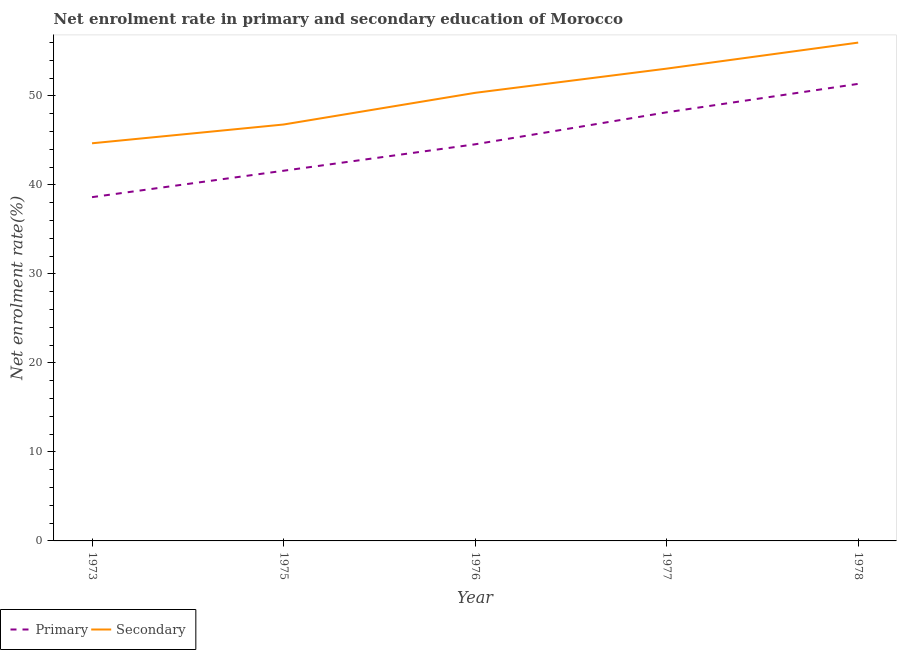How many different coloured lines are there?
Provide a succinct answer. 2. What is the enrollment rate in secondary education in 1977?
Offer a terse response. 53.07. Across all years, what is the maximum enrollment rate in secondary education?
Offer a very short reply. 55.99. Across all years, what is the minimum enrollment rate in primary education?
Offer a very short reply. 38.63. In which year was the enrollment rate in primary education maximum?
Offer a very short reply. 1978. In which year was the enrollment rate in secondary education minimum?
Give a very brief answer. 1973. What is the total enrollment rate in primary education in the graph?
Provide a succinct answer. 224.3. What is the difference between the enrollment rate in secondary education in 1973 and that in 1978?
Offer a terse response. -11.31. What is the difference between the enrollment rate in primary education in 1977 and the enrollment rate in secondary education in 1975?
Offer a terse response. 1.37. What is the average enrollment rate in secondary education per year?
Your answer should be very brief. 50.17. In the year 1976, what is the difference between the enrollment rate in secondary education and enrollment rate in primary education?
Your response must be concise. 5.78. What is the ratio of the enrollment rate in secondary education in 1975 to that in 1978?
Ensure brevity in your answer.  0.84. Is the difference between the enrollment rate in secondary education in 1973 and 1976 greater than the difference between the enrollment rate in primary education in 1973 and 1976?
Give a very brief answer. Yes. What is the difference between the highest and the second highest enrollment rate in secondary education?
Make the answer very short. 2.92. What is the difference between the highest and the lowest enrollment rate in secondary education?
Offer a terse response. 11.31. In how many years, is the enrollment rate in secondary education greater than the average enrollment rate in secondary education taken over all years?
Offer a terse response. 3. Does the enrollment rate in primary education monotonically increase over the years?
Offer a very short reply. Yes. Is the enrollment rate in secondary education strictly greater than the enrollment rate in primary education over the years?
Ensure brevity in your answer.  Yes. Is the enrollment rate in primary education strictly less than the enrollment rate in secondary education over the years?
Make the answer very short. Yes. How many lines are there?
Provide a succinct answer. 2. How many years are there in the graph?
Ensure brevity in your answer.  5. Where does the legend appear in the graph?
Give a very brief answer. Bottom left. How many legend labels are there?
Offer a terse response. 2. How are the legend labels stacked?
Make the answer very short. Horizontal. What is the title of the graph?
Give a very brief answer. Net enrolment rate in primary and secondary education of Morocco. Does "Resident workers" appear as one of the legend labels in the graph?
Offer a very short reply. No. What is the label or title of the Y-axis?
Offer a very short reply. Net enrolment rate(%). What is the Net enrolment rate(%) in Primary in 1973?
Offer a terse response. 38.63. What is the Net enrolment rate(%) in Secondary in 1973?
Offer a terse response. 44.68. What is the Net enrolment rate(%) of Primary in 1975?
Keep it short and to the point. 41.59. What is the Net enrolment rate(%) of Secondary in 1975?
Provide a succinct answer. 46.79. What is the Net enrolment rate(%) of Primary in 1976?
Your answer should be compact. 44.56. What is the Net enrolment rate(%) of Secondary in 1976?
Offer a very short reply. 50.35. What is the Net enrolment rate(%) in Primary in 1977?
Make the answer very short. 48.16. What is the Net enrolment rate(%) of Secondary in 1977?
Offer a terse response. 53.07. What is the Net enrolment rate(%) of Primary in 1978?
Provide a succinct answer. 51.36. What is the Net enrolment rate(%) in Secondary in 1978?
Give a very brief answer. 55.99. Across all years, what is the maximum Net enrolment rate(%) of Primary?
Make the answer very short. 51.36. Across all years, what is the maximum Net enrolment rate(%) of Secondary?
Make the answer very short. 55.99. Across all years, what is the minimum Net enrolment rate(%) of Primary?
Provide a succinct answer. 38.63. Across all years, what is the minimum Net enrolment rate(%) of Secondary?
Your answer should be very brief. 44.68. What is the total Net enrolment rate(%) in Primary in the graph?
Your answer should be very brief. 224.3. What is the total Net enrolment rate(%) in Secondary in the graph?
Keep it short and to the point. 250.87. What is the difference between the Net enrolment rate(%) in Primary in 1973 and that in 1975?
Your answer should be very brief. -2.97. What is the difference between the Net enrolment rate(%) in Secondary in 1973 and that in 1975?
Offer a very short reply. -2.11. What is the difference between the Net enrolment rate(%) of Primary in 1973 and that in 1976?
Make the answer very short. -5.94. What is the difference between the Net enrolment rate(%) in Secondary in 1973 and that in 1976?
Make the answer very short. -5.67. What is the difference between the Net enrolment rate(%) in Primary in 1973 and that in 1977?
Offer a terse response. -9.53. What is the difference between the Net enrolment rate(%) of Secondary in 1973 and that in 1977?
Give a very brief answer. -8.39. What is the difference between the Net enrolment rate(%) of Primary in 1973 and that in 1978?
Give a very brief answer. -12.73. What is the difference between the Net enrolment rate(%) of Secondary in 1973 and that in 1978?
Your answer should be very brief. -11.31. What is the difference between the Net enrolment rate(%) of Primary in 1975 and that in 1976?
Make the answer very short. -2.97. What is the difference between the Net enrolment rate(%) of Secondary in 1975 and that in 1976?
Keep it short and to the point. -3.56. What is the difference between the Net enrolment rate(%) of Primary in 1975 and that in 1977?
Provide a succinct answer. -6.56. What is the difference between the Net enrolment rate(%) of Secondary in 1975 and that in 1977?
Give a very brief answer. -6.28. What is the difference between the Net enrolment rate(%) of Primary in 1975 and that in 1978?
Make the answer very short. -9.76. What is the difference between the Net enrolment rate(%) of Secondary in 1975 and that in 1978?
Offer a terse response. -9.2. What is the difference between the Net enrolment rate(%) of Primary in 1976 and that in 1977?
Ensure brevity in your answer.  -3.59. What is the difference between the Net enrolment rate(%) in Secondary in 1976 and that in 1977?
Ensure brevity in your answer.  -2.72. What is the difference between the Net enrolment rate(%) of Primary in 1976 and that in 1978?
Your answer should be very brief. -6.79. What is the difference between the Net enrolment rate(%) of Secondary in 1976 and that in 1978?
Provide a succinct answer. -5.64. What is the difference between the Net enrolment rate(%) in Primary in 1977 and that in 1978?
Provide a short and direct response. -3.2. What is the difference between the Net enrolment rate(%) of Secondary in 1977 and that in 1978?
Offer a terse response. -2.92. What is the difference between the Net enrolment rate(%) in Primary in 1973 and the Net enrolment rate(%) in Secondary in 1975?
Give a very brief answer. -8.16. What is the difference between the Net enrolment rate(%) of Primary in 1973 and the Net enrolment rate(%) of Secondary in 1976?
Give a very brief answer. -11.72. What is the difference between the Net enrolment rate(%) of Primary in 1973 and the Net enrolment rate(%) of Secondary in 1977?
Your response must be concise. -14.44. What is the difference between the Net enrolment rate(%) in Primary in 1973 and the Net enrolment rate(%) in Secondary in 1978?
Your answer should be very brief. -17.37. What is the difference between the Net enrolment rate(%) of Primary in 1975 and the Net enrolment rate(%) of Secondary in 1976?
Your answer should be very brief. -8.75. What is the difference between the Net enrolment rate(%) of Primary in 1975 and the Net enrolment rate(%) of Secondary in 1977?
Provide a short and direct response. -11.47. What is the difference between the Net enrolment rate(%) in Primary in 1975 and the Net enrolment rate(%) in Secondary in 1978?
Make the answer very short. -14.4. What is the difference between the Net enrolment rate(%) of Primary in 1976 and the Net enrolment rate(%) of Secondary in 1977?
Offer a very short reply. -8.5. What is the difference between the Net enrolment rate(%) of Primary in 1976 and the Net enrolment rate(%) of Secondary in 1978?
Provide a short and direct response. -11.43. What is the difference between the Net enrolment rate(%) in Primary in 1977 and the Net enrolment rate(%) in Secondary in 1978?
Provide a short and direct response. -7.83. What is the average Net enrolment rate(%) in Primary per year?
Make the answer very short. 44.86. What is the average Net enrolment rate(%) in Secondary per year?
Ensure brevity in your answer.  50.17. In the year 1973, what is the difference between the Net enrolment rate(%) of Primary and Net enrolment rate(%) of Secondary?
Keep it short and to the point. -6.05. In the year 1975, what is the difference between the Net enrolment rate(%) in Primary and Net enrolment rate(%) in Secondary?
Ensure brevity in your answer.  -5.19. In the year 1976, what is the difference between the Net enrolment rate(%) of Primary and Net enrolment rate(%) of Secondary?
Your response must be concise. -5.78. In the year 1977, what is the difference between the Net enrolment rate(%) of Primary and Net enrolment rate(%) of Secondary?
Provide a succinct answer. -4.91. In the year 1978, what is the difference between the Net enrolment rate(%) in Primary and Net enrolment rate(%) in Secondary?
Your response must be concise. -4.64. What is the ratio of the Net enrolment rate(%) in Primary in 1973 to that in 1975?
Give a very brief answer. 0.93. What is the ratio of the Net enrolment rate(%) in Secondary in 1973 to that in 1975?
Give a very brief answer. 0.95. What is the ratio of the Net enrolment rate(%) of Primary in 1973 to that in 1976?
Your response must be concise. 0.87. What is the ratio of the Net enrolment rate(%) in Secondary in 1973 to that in 1976?
Ensure brevity in your answer.  0.89. What is the ratio of the Net enrolment rate(%) in Primary in 1973 to that in 1977?
Make the answer very short. 0.8. What is the ratio of the Net enrolment rate(%) of Secondary in 1973 to that in 1977?
Offer a very short reply. 0.84. What is the ratio of the Net enrolment rate(%) of Primary in 1973 to that in 1978?
Make the answer very short. 0.75. What is the ratio of the Net enrolment rate(%) of Secondary in 1973 to that in 1978?
Keep it short and to the point. 0.8. What is the ratio of the Net enrolment rate(%) in Secondary in 1975 to that in 1976?
Make the answer very short. 0.93. What is the ratio of the Net enrolment rate(%) of Primary in 1975 to that in 1977?
Your response must be concise. 0.86. What is the ratio of the Net enrolment rate(%) in Secondary in 1975 to that in 1977?
Keep it short and to the point. 0.88. What is the ratio of the Net enrolment rate(%) of Primary in 1975 to that in 1978?
Give a very brief answer. 0.81. What is the ratio of the Net enrolment rate(%) of Secondary in 1975 to that in 1978?
Provide a succinct answer. 0.84. What is the ratio of the Net enrolment rate(%) of Primary in 1976 to that in 1977?
Make the answer very short. 0.93. What is the ratio of the Net enrolment rate(%) of Secondary in 1976 to that in 1977?
Provide a succinct answer. 0.95. What is the ratio of the Net enrolment rate(%) in Primary in 1976 to that in 1978?
Provide a succinct answer. 0.87. What is the ratio of the Net enrolment rate(%) in Secondary in 1976 to that in 1978?
Your response must be concise. 0.9. What is the ratio of the Net enrolment rate(%) in Primary in 1977 to that in 1978?
Provide a short and direct response. 0.94. What is the ratio of the Net enrolment rate(%) in Secondary in 1977 to that in 1978?
Offer a terse response. 0.95. What is the difference between the highest and the second highest Net enrolment rate(%) in Primary?
Offer a very short reply. 3.2. What is the difference between the highest and the second highest Net enrolment rate(%) in Secondary?
Keep it short and to the point. 2.92. What is the difference between the highest and the lowest Net enrolment rate(%) of Primary?
Your response must be concise. 12.73. What is the difference between the highest and the lowest Net enrolment rate(%) of Secondary?
Offer a terse response. 11.31. 